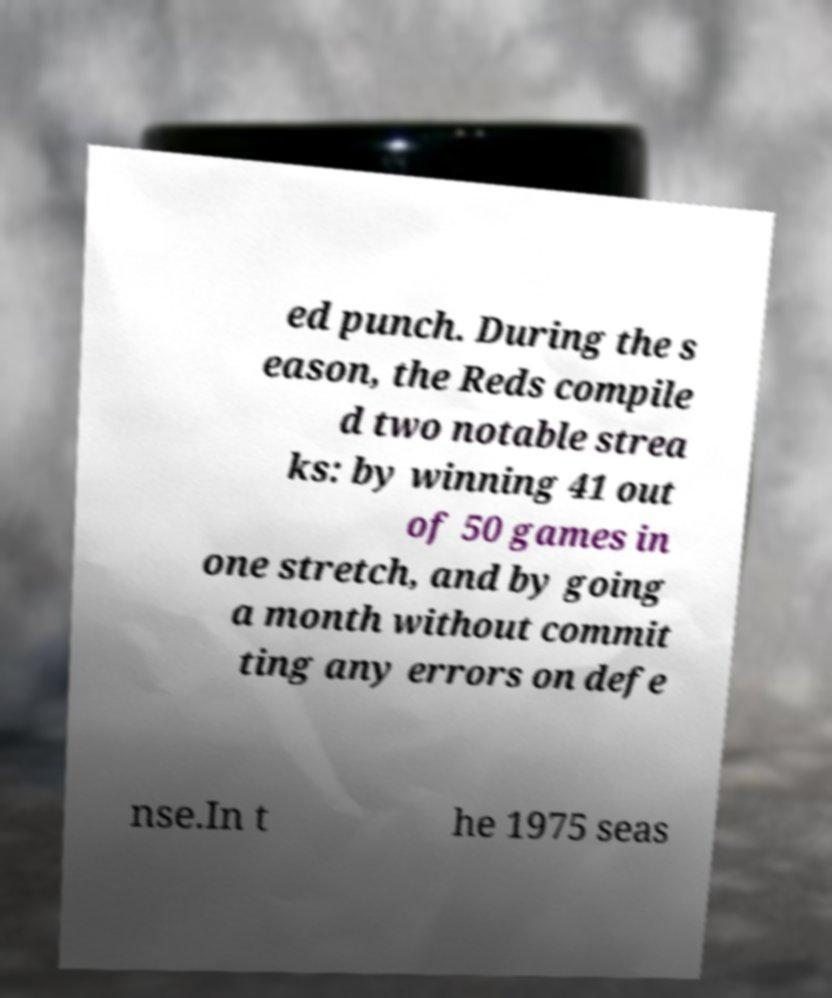Could you assist in decoding the text presented in this image and type it out clearly? ed punch. During the s eason, the Reds compile d two notable strea ks: by winning 41 out of 50 games in one stretch, and by going a month without commit ting any errors on defe nse.In t he 1975 seas 